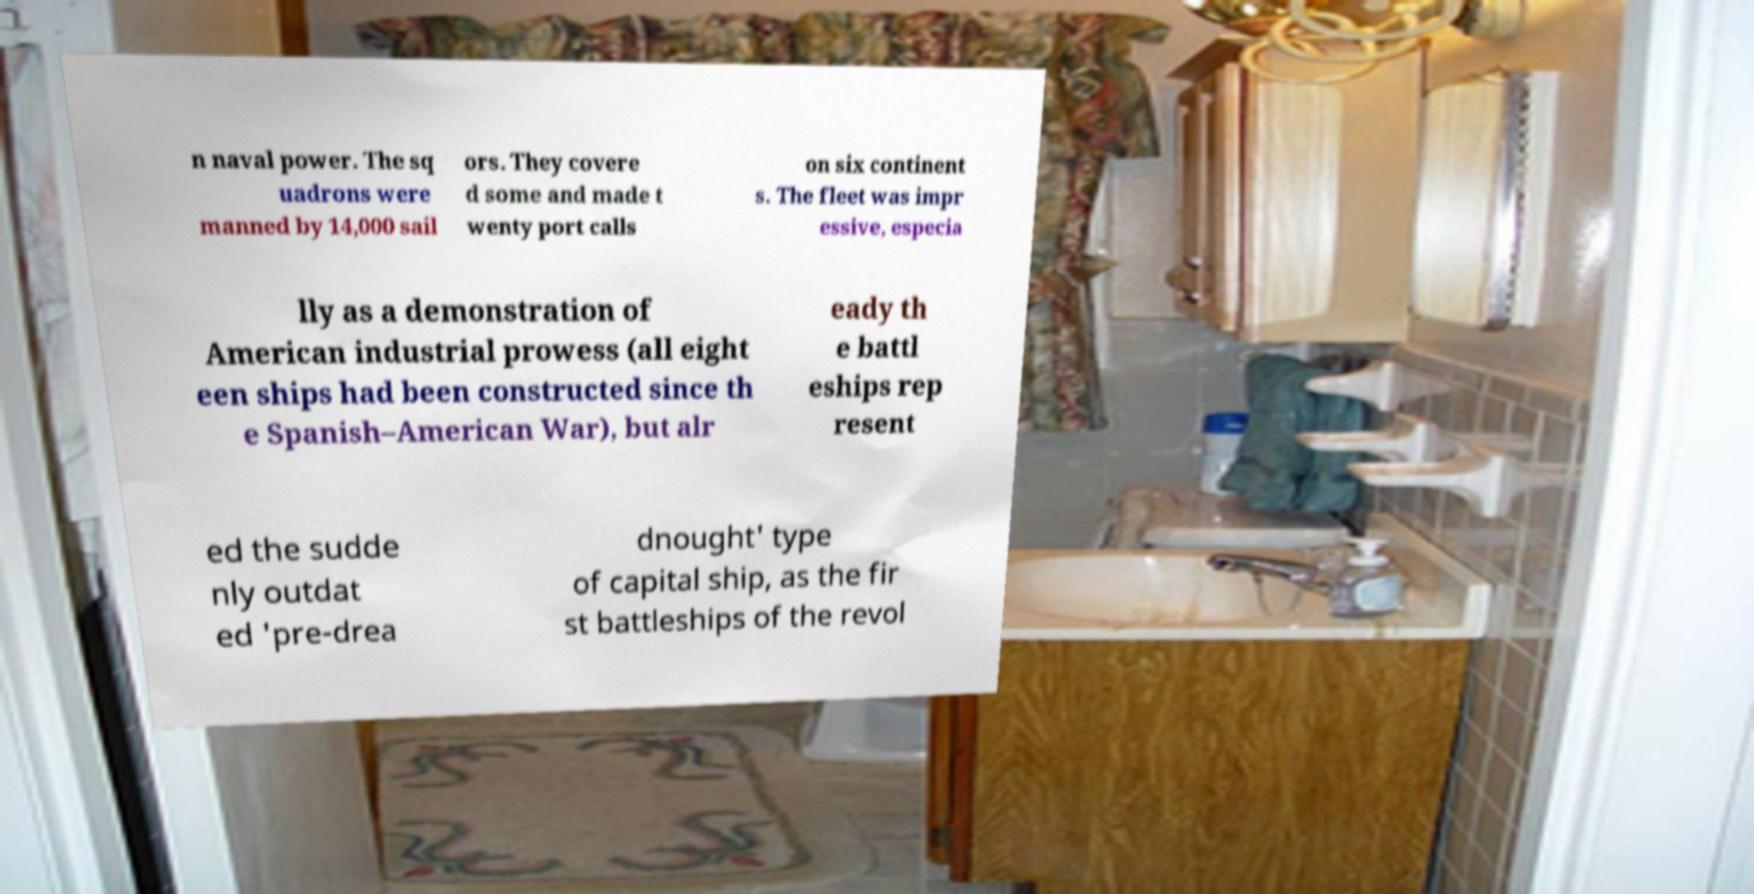Can you accurately transcribe the text from the provided image for me? n naval power. The sq uadrons were manned by 14,000 sail ors. They covere d some and made t wenty port calls on six continent s. The fleet was impr essive, especia lly as a demonstration of American industrial prowess (all eight een ships had been constructed since th e Spanish–American War), but alr eady th e battl eships rep resent ed the sudde nly outdat ed 'pre-drea dnought' type of capital ship, as the fir st battleships of the revol 